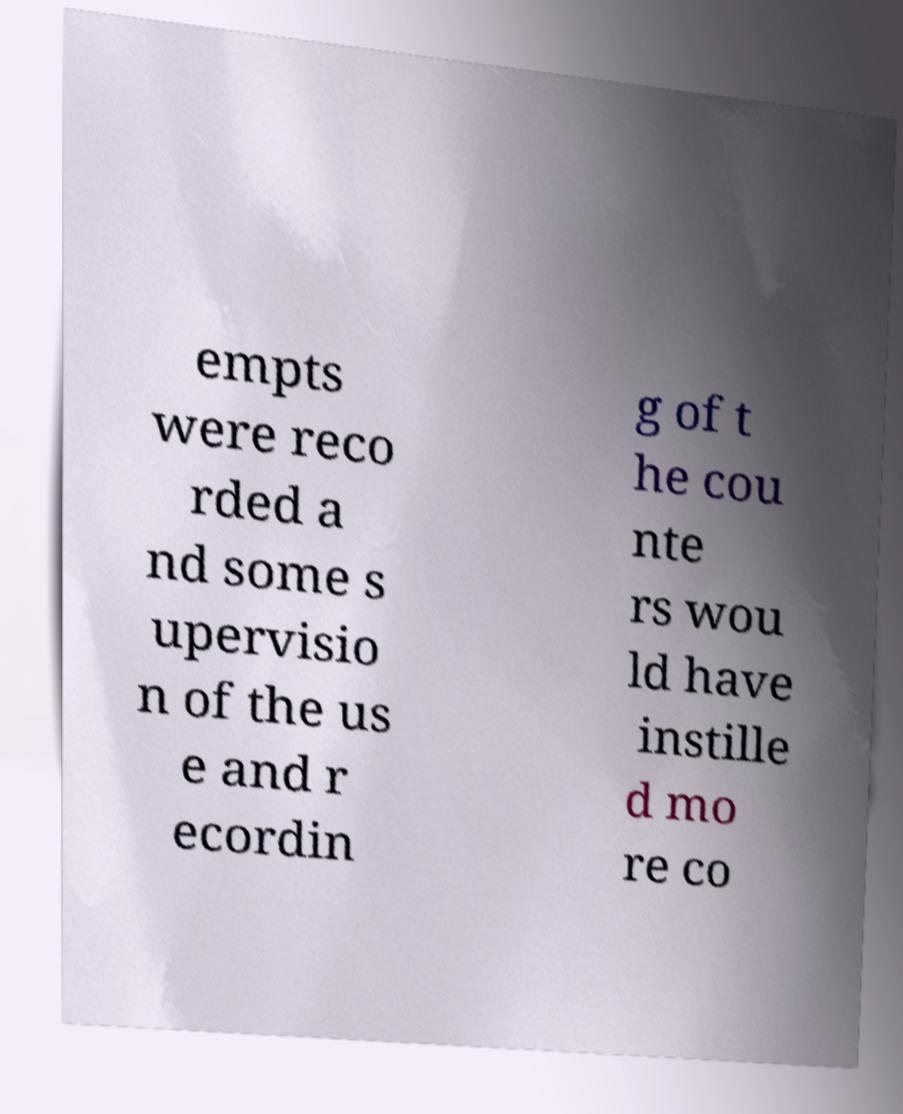I need the written content from this picture converted into text. Can you do that? empts were reco rded a nd some s upervisio n of the us e and r ecordin g of t he cou nte rs wou ld have instille d mo re co 